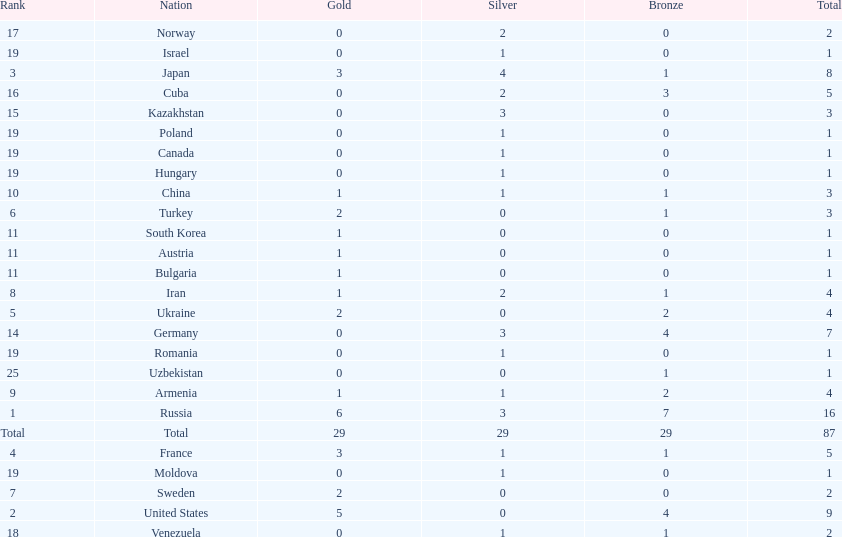Which country won only one medal, a bronze medal? Uzbekistan. 